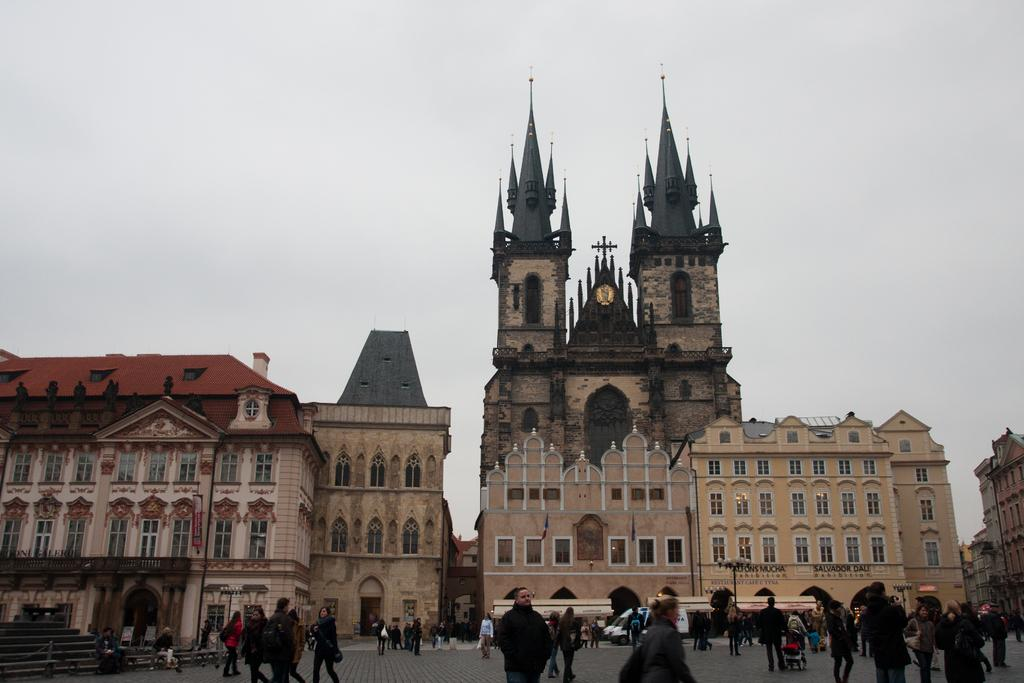What is located in the center of the image? There are buildings in the center of the image. What objects can be seen in the image besides the buildings? There are poles, lights, and stairs visible in the image. What is happening on the road in the image? There are people on the road in the image. What is visible at the top of the image? The sky is visible at the top of the image. What type of grain is being harvested by the people on the road in the image? There is no grain or harvesting activity present in the image; it features buildings, poles, lights, stairs, and people on the road. How much debt is being discussed by the people on the road in the image? There is no discussion of debt or any financial matters present in the image; it features buildings, poles, lights, stairs, and people on the road. 